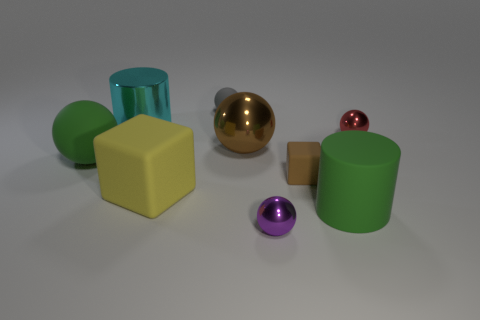Does the large cylinder in front of the tiny brown block have the same color as the large matte ball?
Your response must be concise. Yes. What material is the ball that is the same color as the small rubber cube?
Provide a short and direct response. Metal. Is the material of the big ball to the right of the cyan object the same as the big thing in front of the big yellow rubber object?
Your response must be concise. No. There is a gray object that is the same shape as the large brown thing; what material is it?
Make the answer very short. Rubber. Is the shape of the matte object that is behind the red sphere the same as the big green thing that is to the right of the tiny brown matte object?
Provide a succinct answer. No. Are there fewer brown rubber things on the left side of the small gray rubber sphere than things that are in front of the green rubber cylinder?
Provide a short and direct response. Yes. What number of other things are there of the same shape as the cyan thing?
Make the answer very short. 1. There is a green thing that is made of the same material as the big green cylinder; what is its shape?
Your response must be concise. Sphere. The tiny sphere that is both behind the brown rubber object and to the left of the red ball is what color?
Provide a succinct answer. Gray. Does the large green object that is to the left of the tiny rubber cube have the same material as the brown ball?
Ensure brevity in your answer.  No. 